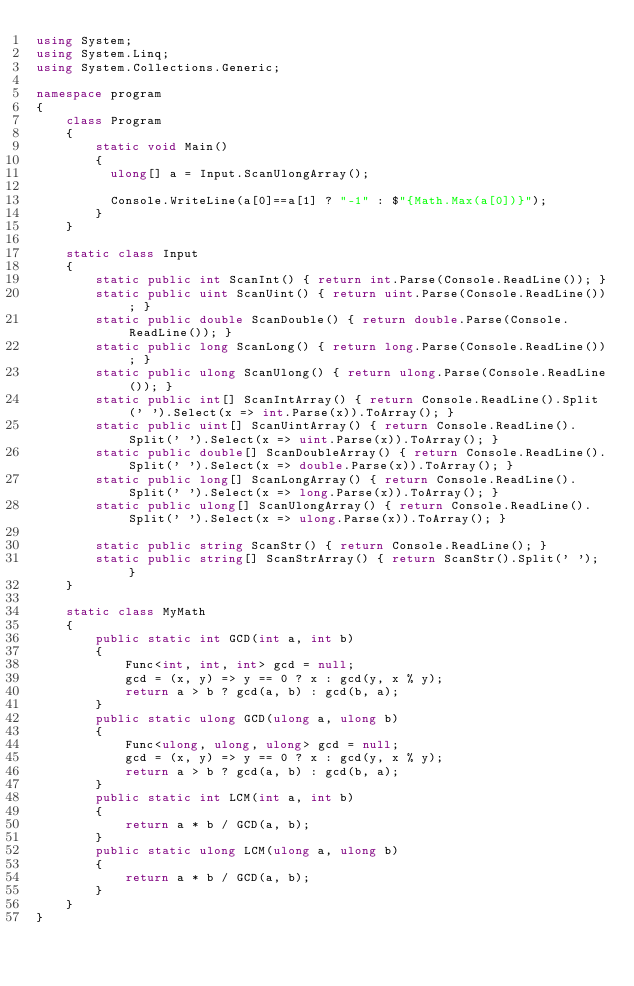<code> <loc_0><loc_0><loc_500><loc_500><_C#_>using System;
using System.Linq;
using System.Collections.Generic;

namespace program
{
    class Program
    {
        static void Main()
        {
          ulong[] a = Input.ScanUlongArray();
          
          Console.WriteLine(a[0]==a[1] ? "-1" : $"{Math.Max(a[0])}");
        }
    }

    static class Input
    {
        static public int ScanInt() { return int.Parse(Console.ReadLine()); }
        static public uint ScanUint() { return uint.Parse(Console.ReadLine()); }
        static public double ScanDouble() { return double.Parse(Console.ReadLine()); }
        static public long ScanLong() { return long.Parse(Console.ReadLine()); }
        static public ulong ScanUlong() { return ulong.Parse(Console.ReadLine()); }
        static public int[] ScanIntArray() { return Console.ReadLine().Split(' ').Select(x => int.Parse(x)).ToArray(); }
        static public uint[] ScanUintArray() { return Console.ReadLine().Split(' ').Select(x => uint.Parse(x)).ToArray(); }
        static public double[] ScanDoubleArray() { return Console.ReadLine().Split(' ').Select(x => double.Parse(x)).ToArray(); }
        static public long[] ScanLongArray() { return Console.ReadLine().Split(' ').Select(x => long.Parse(x)).ToArray(); }
        static public ulong[] ScanUlongArray() { return Console.ReadLine().Split(' ').Select(x => ulong.Parse(x)).ToArray(); }

        static public string ScanStr() { return Console.ReadLine(); }
        static public string[] ScanStrArray() { return ScanStr().Split(' '); }
    }

    static class MyMath
    {
        public static int GCD(int a, int b)
        {
            Func<int, int, int> gcd = null;
            gcd = (x, y) => y == 0 ? x : gcd(y, x % y);
            return a > b ? gcd(a, b) : gcd(b, a);
        }
        public static ulong GCD(ulong a, ulong b)
        {
            Func<ulong, ulong, ulong> gcd = null;
            gcd = (x, y) => y == 0 ? x : gcd(y, x % y);
            return a > b ? gcd(a, b) : gcd(b, a);
        }
        public static int LCM(int a, int b)
        {
            return a * b / GCD(a, b);
        }
        public static ulong LCM(ulong a, ulong b)
        {
            return a * b / GCD(a, b);
        }
    }
}
</code> 